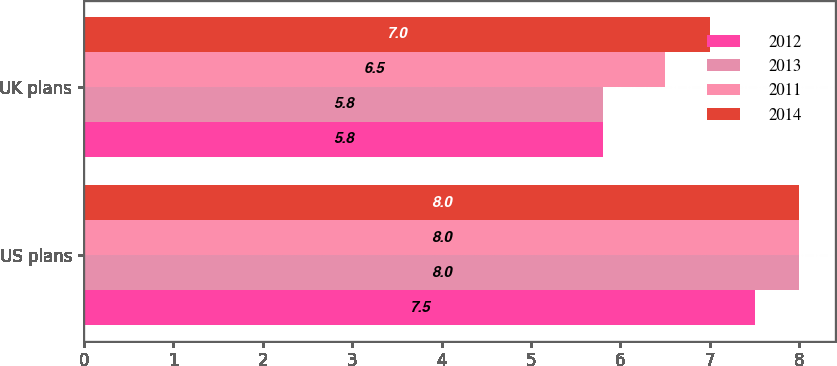Convert chart to OTSL. <chart><loc_0><loc_0><loc_500><loc_500><stacked_bar_chart><ecel><fcel>US plans<fcel>UK plans<nl><fcel>2012<fcel>7.5<fcel>5.8<nl><fcel>2013<fcel>8<fcel>5.8<nl><fcel>2011<fcel>8<fcel>6.5<nl><fcel>2014<fcel>8<fcel>7<nl></chart> 